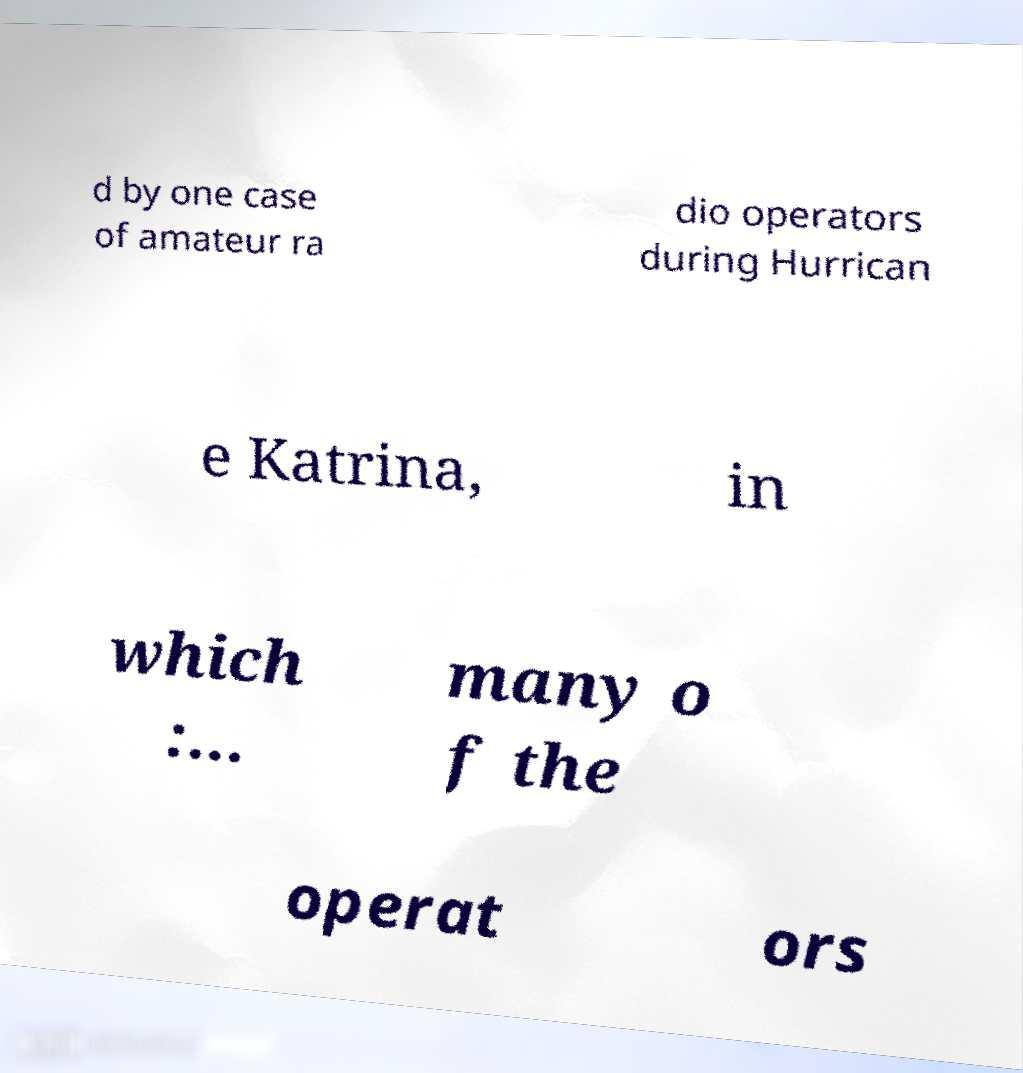Could you extract and type out the text from this image? d by one case of amateur ra dio operators during Hurrican e Katrina, in which :... many o f the operat ors 